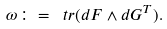Convert formula to latex. <formula><loc_0><loc_0><loc_500><loc_500>\omega \colon = \ t r ( d F \wedge d G ^ { T } ) .</formula> 